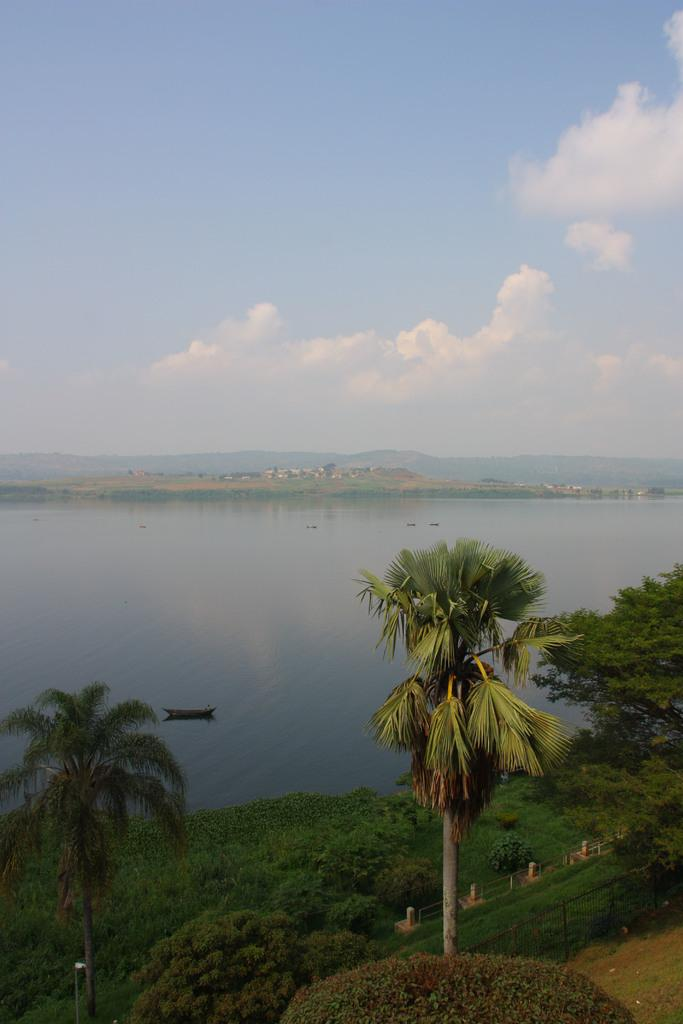What type of natural environment is depicted in the image? The image features trees, water, hills, and a cloudy sky. Can you describe the water in the image? There are boats in the water and the path. What type of transportation can be seen in the image? Boats are present in the water and the path. Where is the mailbox located in the image? There is no mailbox present in the image. How many rabbits can be seen hopping around in the image? There are no rabbits present in the image. 